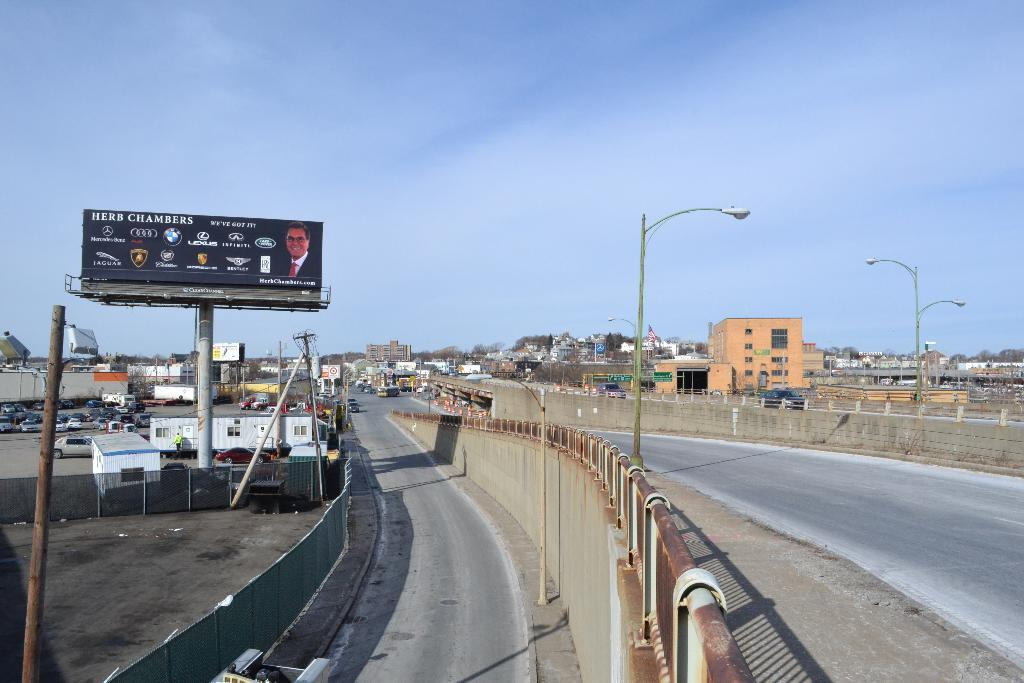<image>
Offer a succinct explanation of the picture presented. A billboard for Herb Chambers is by the road. 